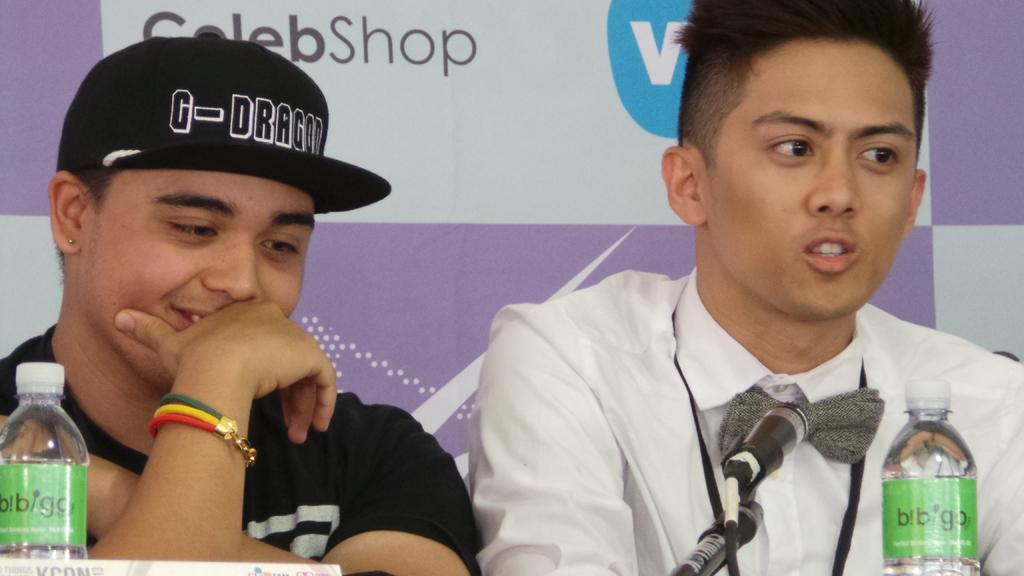What is the man in the image wearing on his head? The man is wearing a cap in the image. What type of clothing is the man wearing on his upper body? The man is wearing a black t-shirt and a white shirt in the image. What objects are in front of the man? There is a bottle and a microphone (mic) in front of the man in the image. What type of straw is the man holding in the image? There is no straw present in the image. 